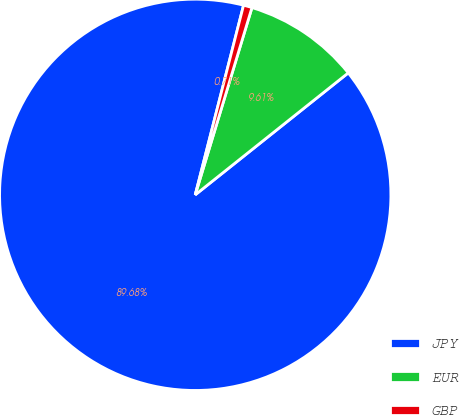Convert chart. <chart><loc_0><loc_0><loc_500><loc_500><pie_chart><fcel>JPY<fcel>EUR<fcel>GBP<nl><fcel>89.68%<fcel>9.61%<fcel>0.71%<nl></chart> 